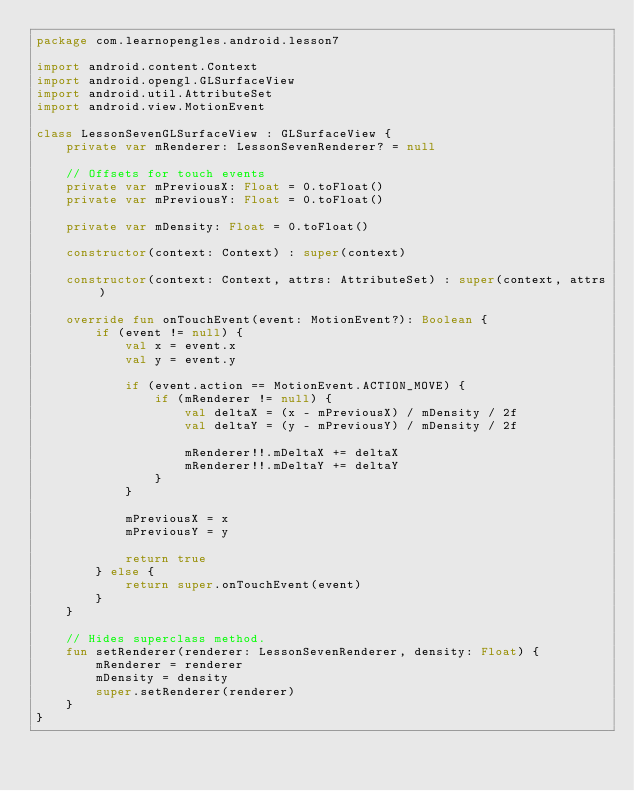Convert code to text. <code><loc_0><loc_0><loc_500><loc_500><_Kotlin_>package com.learnopengles.android.lesson7

import android.content.Context
import android.opengl.GLSurfaceView
import android.util.AttributeSet
import android.view.MotionEvent

class LessonSevenGLSurfaceView : GLSurfaceView {
    private var mRenderer: LessonSevenRenderer? = null

    // Offsets for touch events
    private var mPreviousX: Float = 0.toFloat()
    private var mPreviousY: Float = 0.toFloat()

    private var mDensity: Float = 0.toFloat()

    constructor(context: Context) : super(context)

    constructor(context: Context, attrs: AttributeSet) : super(context, attrs)

    override fun onTouchEvent(event: MotionEvent?): Boolean {
        if (event != null) {
            val x = event.x
            val y = event.y

            if (event.action == MotionEvent.ACTION_MOVE) {
                if (mRenderer != null) {
                    val deltaX = (x - mPreviousX) / mDensity / 2f
                    val deltaY = (y - mPreviousY) / mDensity / 2f

                    mRenderer!!.mDeltaX += deltaX
                    mRenderer!!.mDeltaY += deltaY
                }
            }

            mPreviousX = x
            mPreviousY = y

            return true
        } else {
            return super.onTouchEvent(event)
        }
    }

    // Hides superclass method.
    fun setRenderer(renderer: LessonSevenRenderer, density: Float) {
        mRenderer = renderer
        mDensity = density
        super.setRenderer(renderer)
    }
}
</code> 